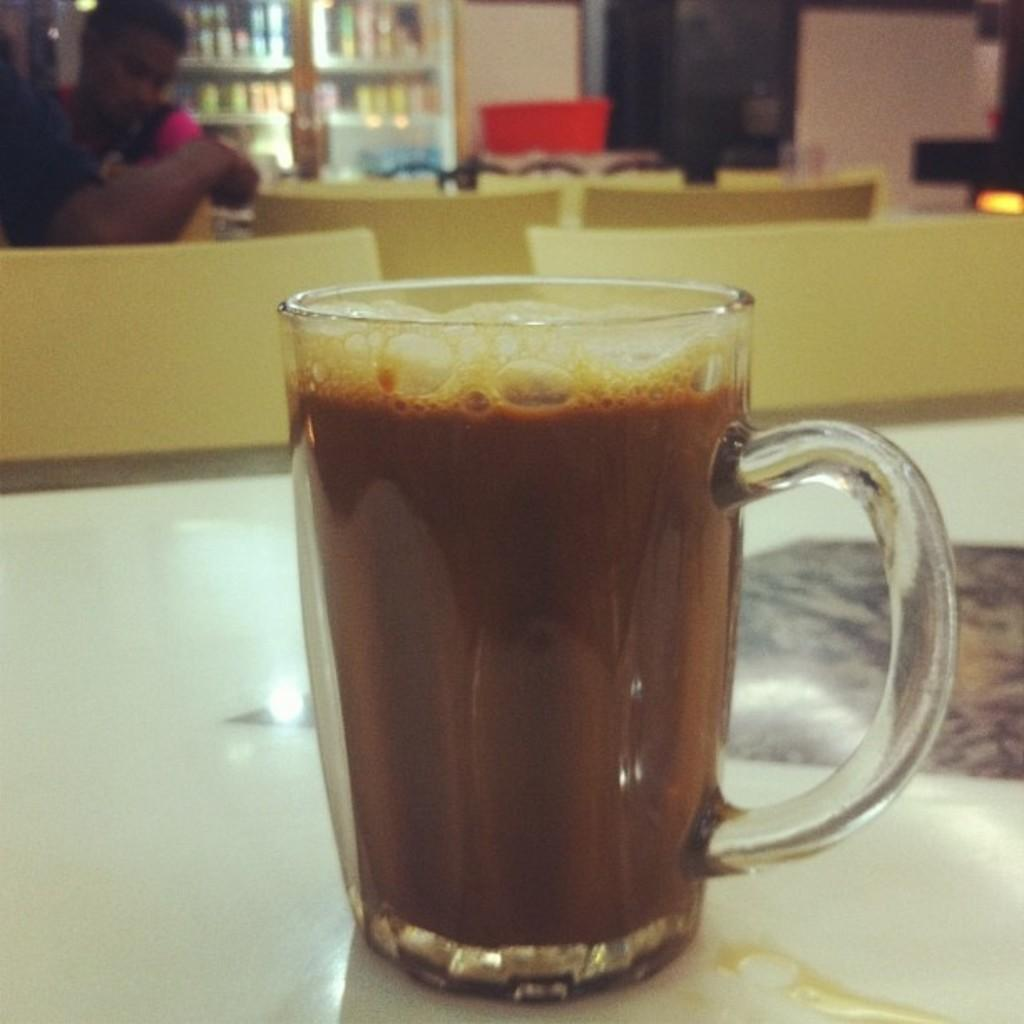What is in the cup that is visible in the image? The cup contains a drink. What can be seen in the background of the image? There are chairs, two people, a wall, books, and some objects in the background of the image. How many people are visible in the image? There are two people visible in the image, both in the background. What type of objects can be seen in the background of the image? There are chairs, books, and some unspecified objects in the background of the image. What type of nail is being hammered into the wall in the image? There is no nail being hammered into the wall in the image. 